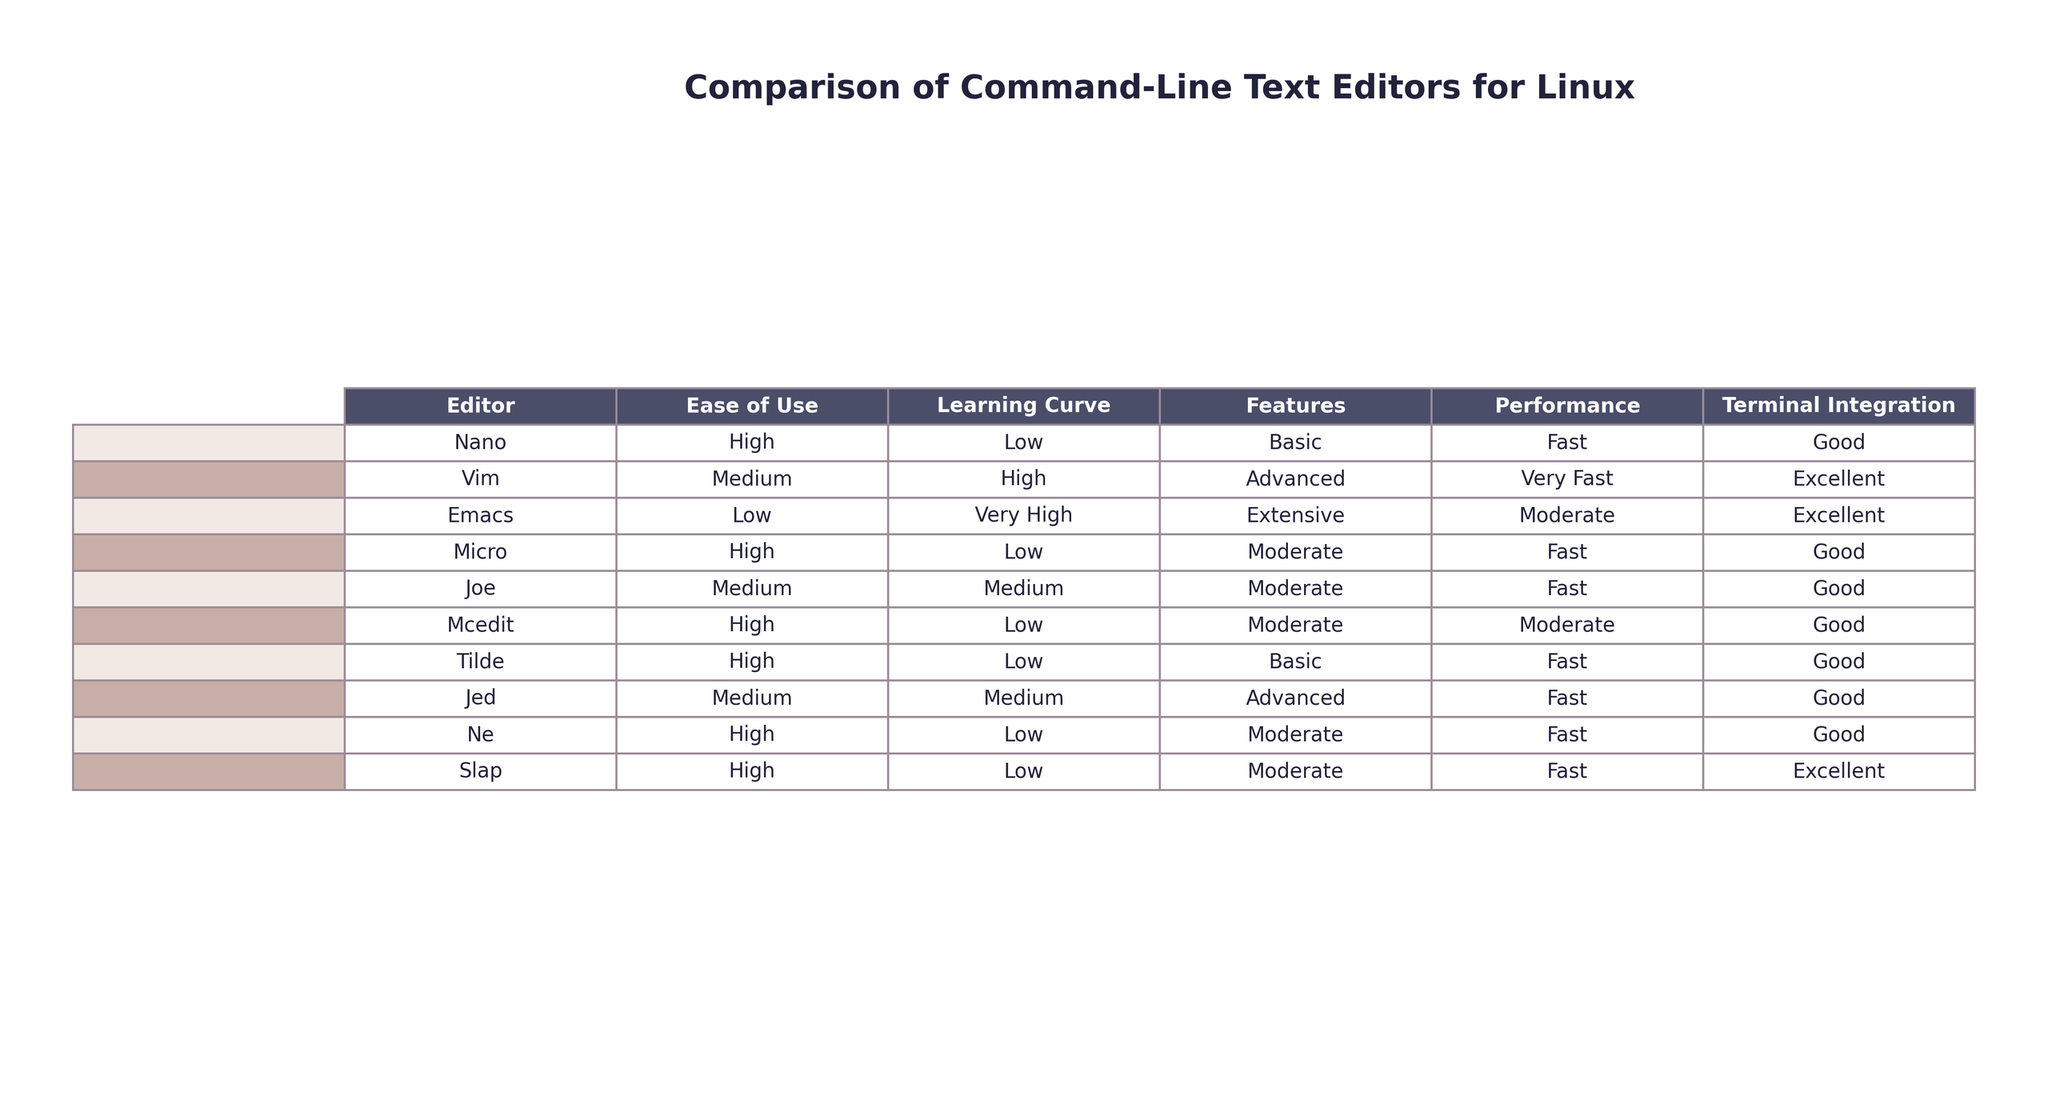What is the easiest text editor to use according to the table? The table indicates that Nano, Micro, Mcedit, Tilde, Ne, and Slap all have a high ease of use rating. The first one listed is Nano, which is the easiest to use.
Answer: Nano Which text editor has the highest learning curve? Emacs is listed with a very high learning curve, making it the editor with the highest difficulty in terms of learning how to use it.
Answer: Emacs How do the features of Vim compare to those of Joe? Vim is categorized with advanced features, while Joe has moderate features. Hence, Vim offers more features than Joe.
Answer: Vim has more features What is the fastest text editor mentioned in the table? The performance of editors is provided, and both Vim, Nano, Micro, Joe, Tilde, Ne, and Slap are noted to be fast, but Vim is labeled as very fast, making it the fastest overall.
Answer: Vim Which text editor provides excellent terminal integration? The table indicates that both Vim and Emacs have excellent terminal integration, along with Slap. Therefore, the editors with excellent integration are Vim, Emacs, and Slap.
Answer: Vim, Emacs, Slap If you were to pick an editor based on moderate features and fast performance, which editors would you consider? The table shows Joe, Mcedit, and Ne all having moderate features and fast performance. Therefore, these are the editors to consider.
Answer: Joe, Mcedit, Ne Is there any text editor that has both high ease of use and fast performance? Yes, both Nano and Micro have high ease of use and are rated as fast in performance.
Answer: Yes Which editor is the least easy to use and has extensive features? Emacs is labeled with low ease of use and extensive features, making it the least easy to use editor with extensive features.
Answer: Emacs How many text editors have a low learning curve according to the table? The editors Nano, Micro, Mcedit, Tilde, Ne, and Slap are marked with a low learning curve, totaling six editors in this category.
Answer: Six What percentage of the editors categorized as medium ease of use have advanced features? There are four editors classified as having medium ease of use (Vim, Joe, Jed), and among these, only Vim and Jed are categorized with advanced features, which is 2 out of 4. The percentage is (2/4) * 100 = 50%.
Answer: 50% 